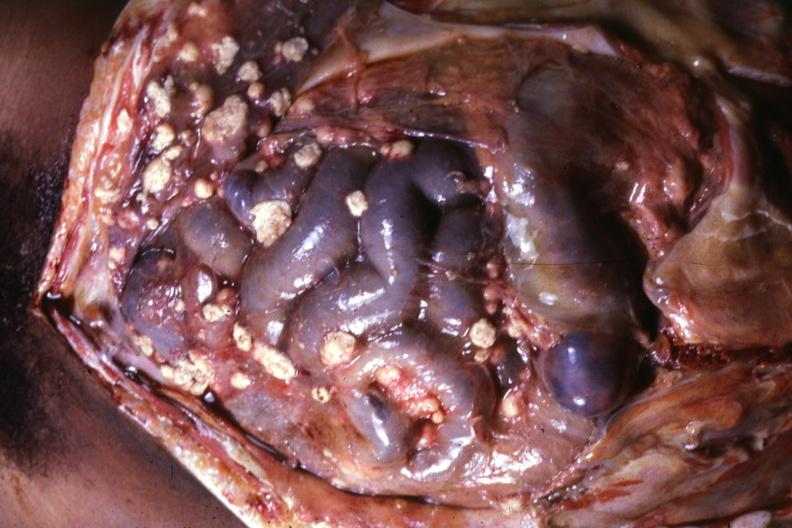does subdiaphragmatic abscess show opened abdominal cavity with atypically large lesions looking more like metastatic carcinoma?
Answer the question using a single word or phrase. No 